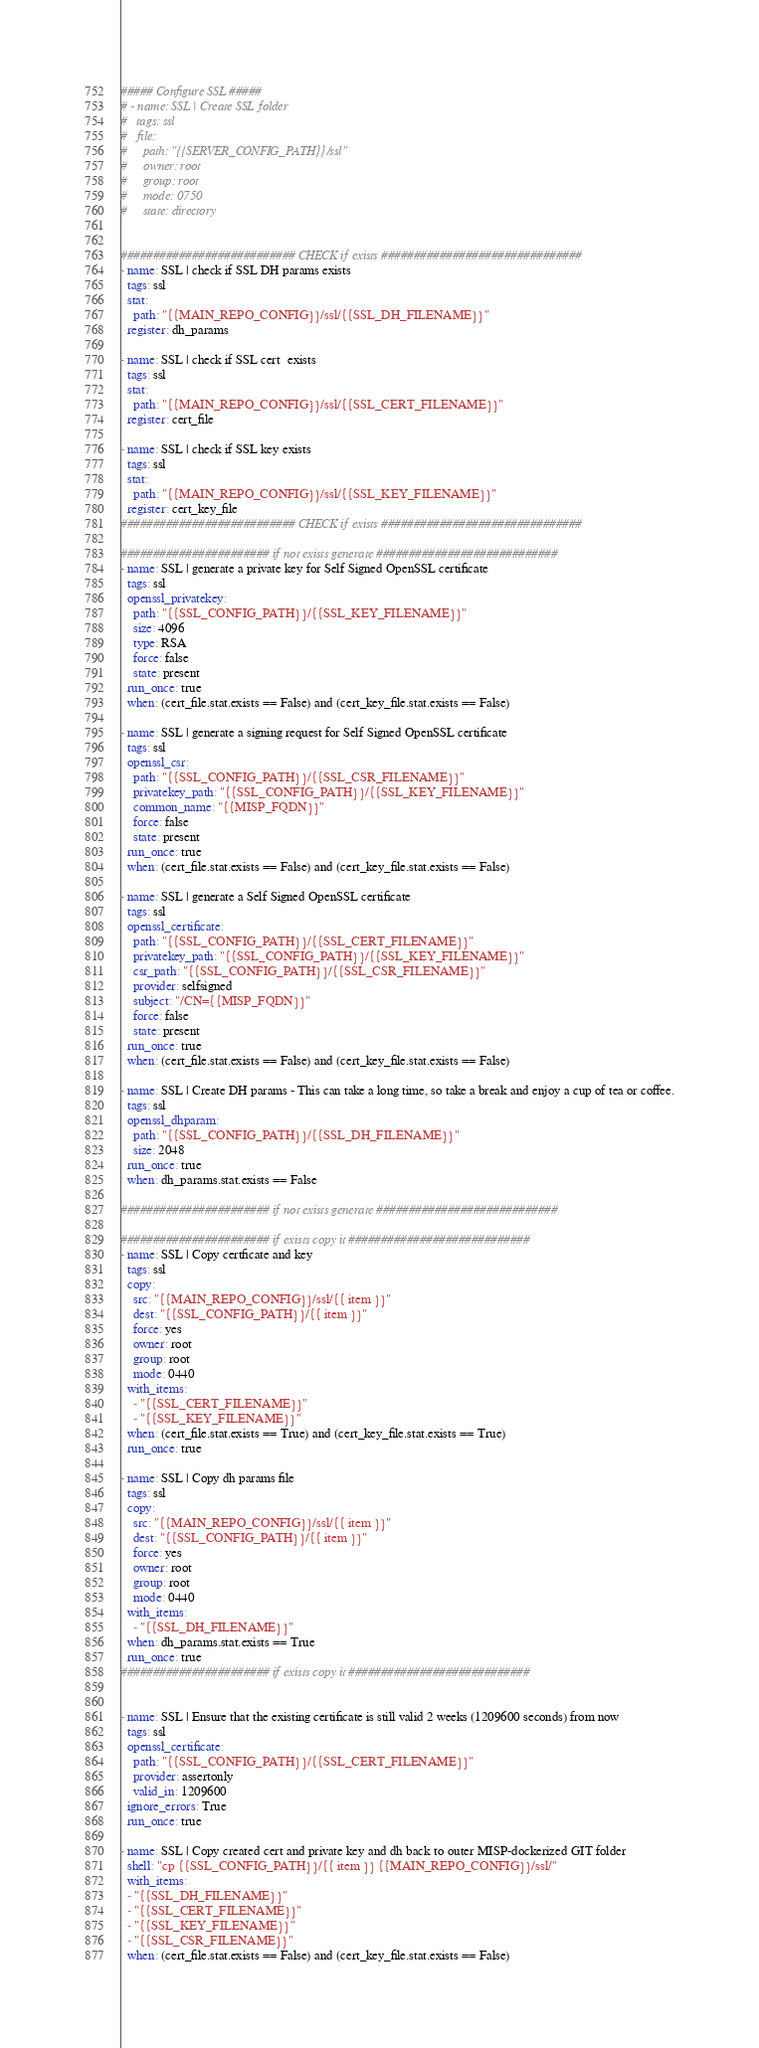Convert code to text. <code><loc_0><loc_0><loc_500><loc_500><_YAML_>##### Configure SSL #####
# - name: SSL | Create SSL folder
#   tags: ssl
#   file:
#     path: "{{SERVER_CONFIG_PATH}}/ssl"
#     owner: root
#     group: root
#     mode: 0750
#     state: directory


########################### CHECK if exists ###############################
- name: SSL | check if SSL DH params exists
  tags: ssl
  stat: 
    path: "{{MAIN_REPO_CONFIG}}/ssl/{{SSL_DH_FILENAME}}"
  register: dh_params

- name: SSL | check if SSL cert  exists
  tags: ssl
  stat: 
    path: "{{MAIN_REPO_CONFIG}}/ssl/{{SSL_CERT_FILENAME}}"
  register: cert_file

- name: SSL | check if SSL key exists
  tags: ssl
  stat: 
    path: "{{MAIN_REPO_CONFIG}}/ssl/{{SSL_KEY_FILENAME}}"
  register: cert_key_file
########################### CHECK if exists ###############################

####################### if not exists generate ############################ 
- name: SSL | generate a private key for Self Signed OpenSSL certificate
  tags: ssl
  openssl_privatekey:
    path: "{{SSL_CONFIG_PATH}}/{{SSL_KEY_FILENAME}}"
    size: 4096
    type: RSA
    force: false
    state: present
  run_once: true
  when: (cert_file.stat.exists == False) and (cert_key_file.stat.exists == False)

- name: SSL | generate a signing request for Self Signed OpenSSL certificate
  tags: ssl
  openssl_csr:
    path: "{{SSL_CONFIG_PATH}}/{{SSL_CSR_FILENAME}}"
    privatekey_path: "{{SSL_CONFIG_PATH}}/{{SSL_KEY_FILENAME}}"
    common_name: "{{MISP_FQDN}}"
    force: false
    state: present
  run_once: true
  when: (cert_file.stat.exists == False) and (cert_key_file.stat.exists == False)

- name: SSL | generate a Self Signed OpenSSL certificate
  tags: ssl
  openssl_certificate:
    path: "{{SSL_CONFIG_PATH}}/{{SSL_CERT_FILENAME}}"
    privatekey_path: "{{SSL_CONFIG_PATH}}/{{SSL_KEY_FILENAME}}"
    csr_path: "{{SSL_CONFIG_PATH}}/{{SSL_CSR_FILENAME}}"
    provider: selfsigned
    subject: "/CN={{MISP_FQDN}}"
    force: false
    state: present
  run_once: true
  when: (cert_file.stat.exists == False) and (cert_key_file.stat.exists == False)

- name: SSL | Create DH params - This can take a long time, so take a break and enjoy a cup of tea or coffee.
  tags: ssl
  openssl_dhparam:
    path: "{{SSL_CONFIG_PATH}}/{{SSL_DH_FILENAME}}"
    size: 2048
  run_once: true
  when: dh_params.stat.exists == False

####################### if not exists generate ############################ 

####################### if exists copy it ############################ 
- name: SSL | Copy certficate and key
  tags: ssl
  copy:
    src: "{{MAIN_REPO_CONFIG}}/ssl/{{ item }}"
    dest: "{{SSL_CONFIG_PATH}}/{{ item }}"
    force: yes
    owner: root
    group: root
    mode: 0440
  with_items:
    - "{{SSL_CERT_FILENAME}}"
    - "{{SSL_KEY_FILENAME}}"
  when: (cert_file.stat.exists == True) and (cert_key_file.stat.exists == True) 
  run_once: true

- name: SSL | Copy dh params file
  tags: ssl
  copy:
    src: "{{MAIN_REPO_CONFIG}}/ssl/{{ item }}"
    dest: "{{SSL_CONFIG_PATH}}/{{ item }}"
    force: yes
    owner: root
    group: root
    mode: 0440
  with_items:
    - "{{SSL_DH_FILENAME}}"
  when: dh_params.stat.exists == True 
  run_once: true
####################### if exists copy it ############################ 


- name: SSL | Ensure that the existing certificate is still valid 2 weeks (1209600 seconds) from now
  tags: ssl
  openssl_certificate:
    path: "{{SSL_CONFIG_PATH}}/{{SSL_CERT_FILENAME}}"
    provider: assertonly
    valid_in: 1209600
  ignore_errors: True
  run_once: true

- name: SSL | Copy created cert and private key and dh back to outer MISP-dockerized GIT folder
  shell: "cp {{SSL_CONFIG_PATH}}/{{ item }} {{MAIN_REPO_CONFIG}}/ssl/"
  with_items:
  - "{{SSL_DH_FILENAME}}"
  - "{{SSL_CERT_FILENAME}}"
  - "{{SSL_KEY_FILENAME}}"
  - "{{SSL_CSR_FILENAME}}"
  when: (cert_file.stat.exists == False) and (cert_key_file.stat.exists == False)</code> 